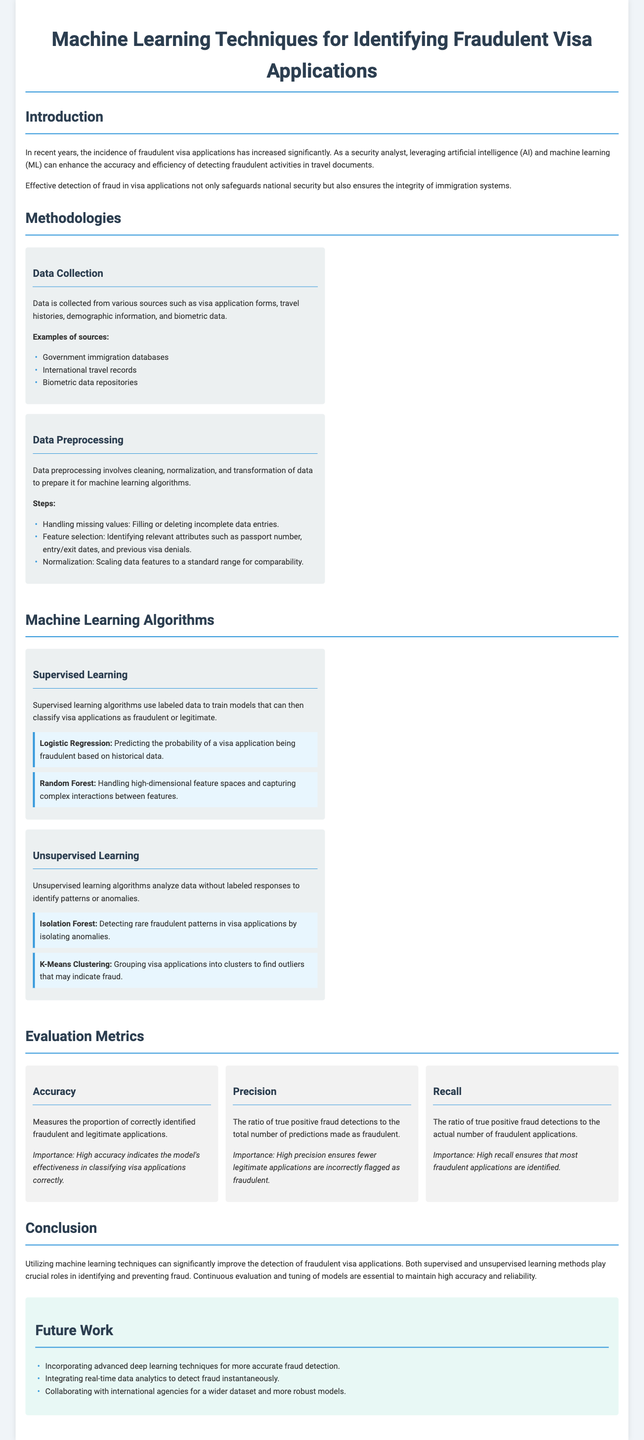What is the main focus of the lab report? The report's main focus is on enhancing the accuracy and efficiency of detecting fraudulent activities in travel documents using AI and ML techniques.
Answer: detecting fraudulent activities What algorithms are used in supervised learning? The supervised learning algorithms mentioned are Logistic Regression and Random Forest.
Answer: Logistic Regression, Random Forest What metric measures the proportion of correctly identified applications? The metric that measures this proportion is Accuracy.
Answer: Accuracy What is one example of a data source for data collection? One example of a data source mentioned is Government immigration databases.
Answer: Government immigration databases What is the importance of high precision? High precision ensures fewer legitimate applications are incorrectly flagged as fraudulent.
Answer: fewer legitimate applications flagged What technique is suggested for future work in fraud detection? An advanced technique suggested for future work is incorporating deep learning.
Answer: deep learning techniques What is done during the data preprocessing step? Data preprocessing involves cleaning, normalization, and transformation of data.
Answer: cleaning, normalization, transformation How many methodologies are described in the document? The document describes two main methodologies: Data Collection and Data Preprocessing.
Answer: two 